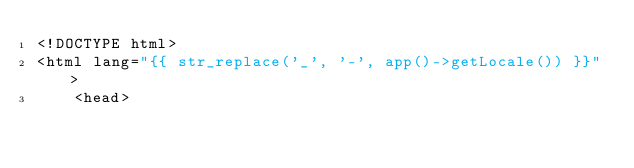<code> <loc_0><loc_0><loc_500><loc_500><_PHP_><!DOCTYPE html>
<html lang="{{ str_replace('_', '-', app()->getLocale()) }}">
    <head>
</code> 